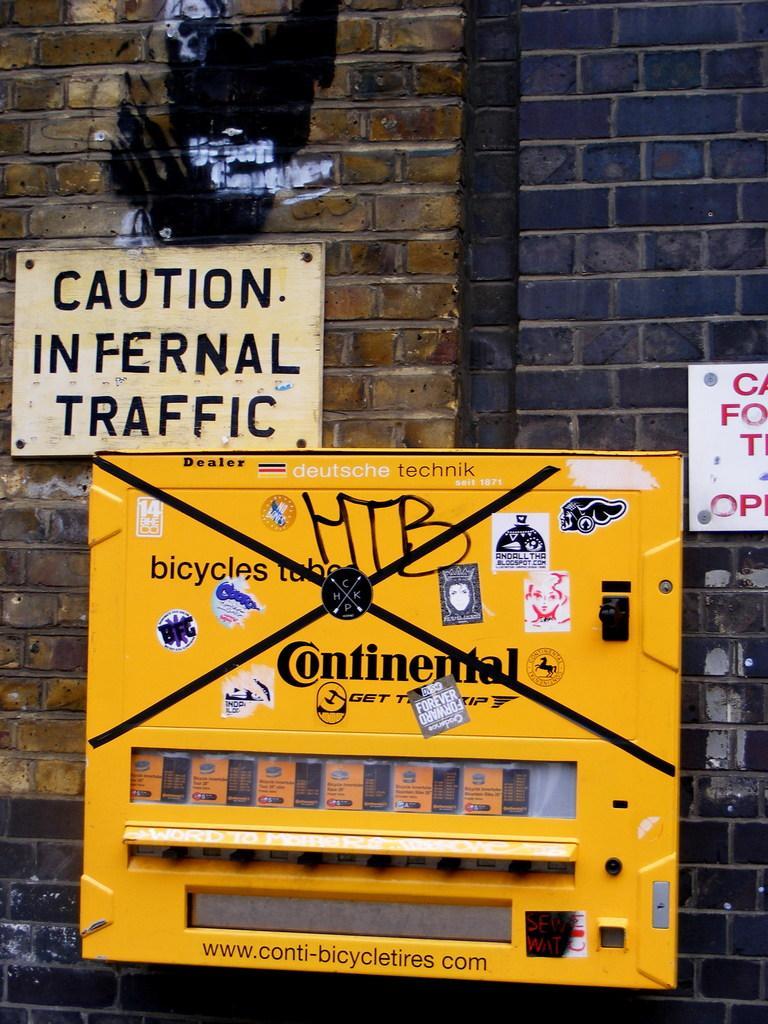In one or two sentences, can you explain what this image depicts? In this image I can see the machine in yellow color, background I can see few boards attached to the wall and the wall is in brown and black color. 